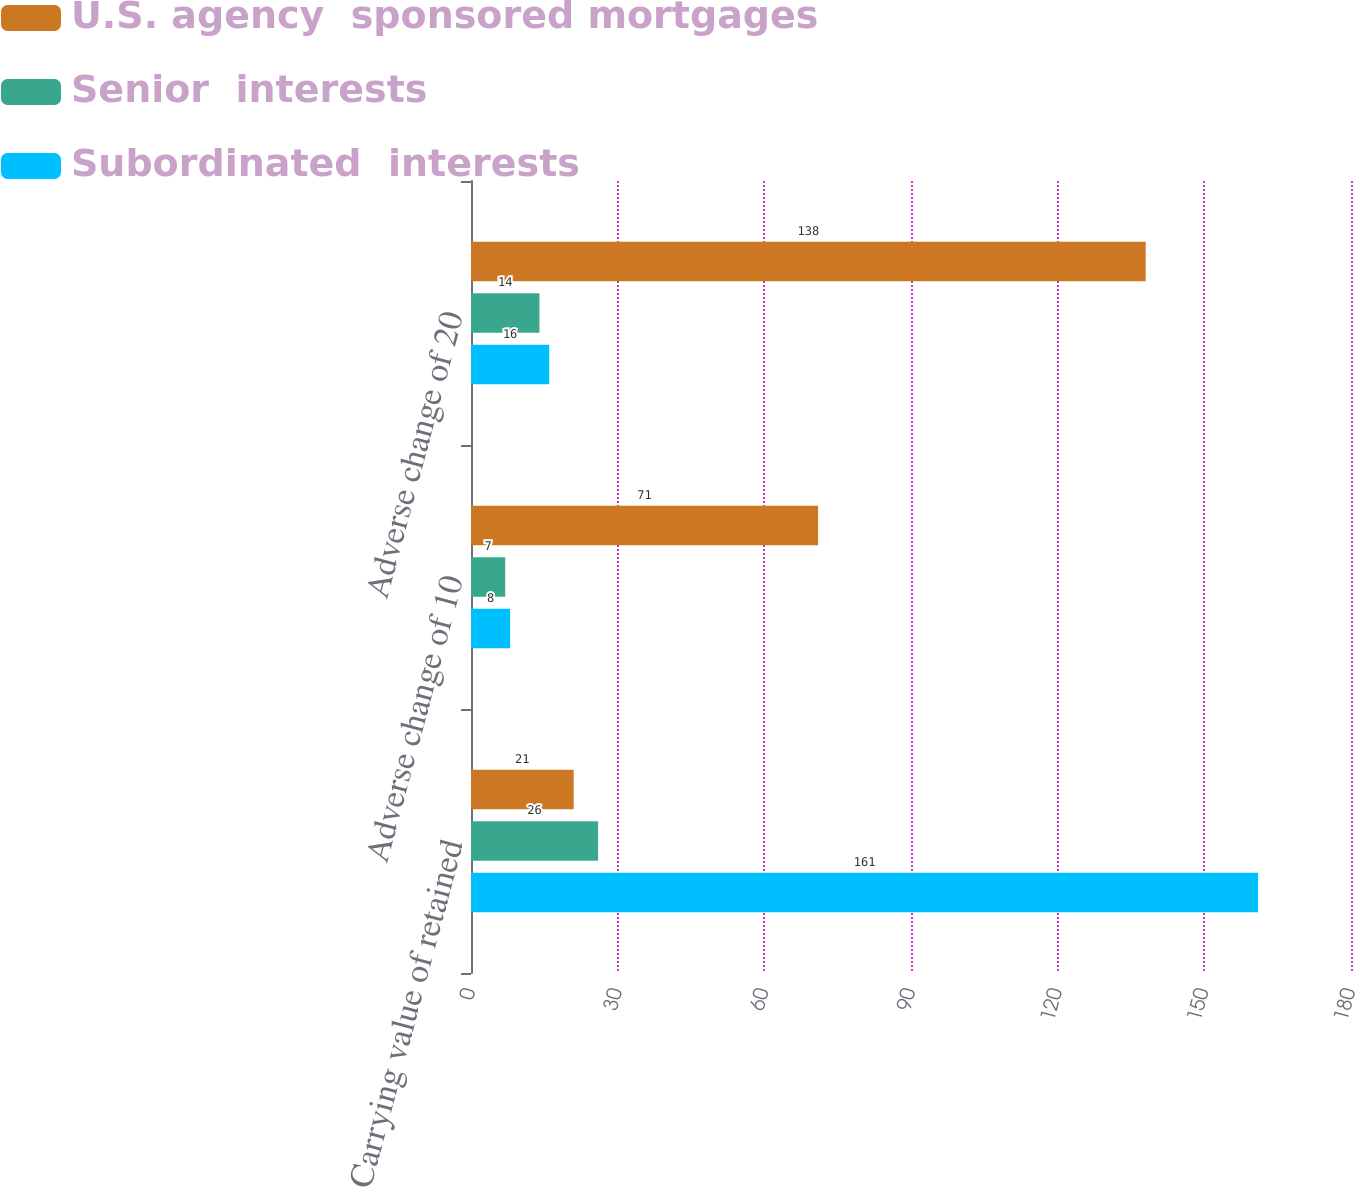Convert chart to OTSL. <chart><loc_0><loc_0><loc_500><loc_500><stacked_bar_chart><ecel><fcel>Carrying value of retained<fcel>Adverse change of 10<fcel>Adverse change of 20<nl><fcel>U.S. agency  sponsored mortgages<fcel>21<fcel>71<fcel>138<nl><fcel>Senior  interests<fcel>26<fcel>7<fcel>14<nl><fcel>Subordinated  interests<fcel>161<fcel>8<fcel>16<nl></chart> 